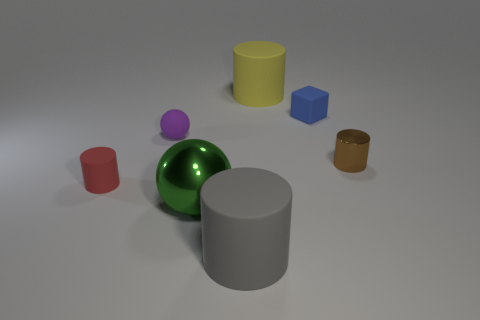What size is the thing in front of the green thing left of the tiny blue matte object?
Provide a short and direct response. Large. There is a green thing that is the same shape as the purple matte thing; what is it made of?
Offer a very short reply. Metal. How many big gray matte objects are there?
Your answer should be very brief. 1. The large cylinder that is left of the rubber cylinder that is behind the shiny thing that is right of the big gray thing is what color?
Give a very brief answer. Gray. Is the number of big blue metallic cylinders less than the number of tiny blue cubes?
Offer a terse response. Yes. There is a tiny object that is the same shape as the big green metal object; what color is it?
Keep it short and to the point. Purple. What is the color of the small ball that is the same material as the big yellow cylinder?
Make the answer very short. Purple. How many matte objects are the same size as the shiny sphere?
Offer a terse response. 2. What is the material of the small brown thing?
Make the answer very short. Metal. Is the number of small cyan metal spheres greater than the number of matte cubes?
Your response must be concise. No. 